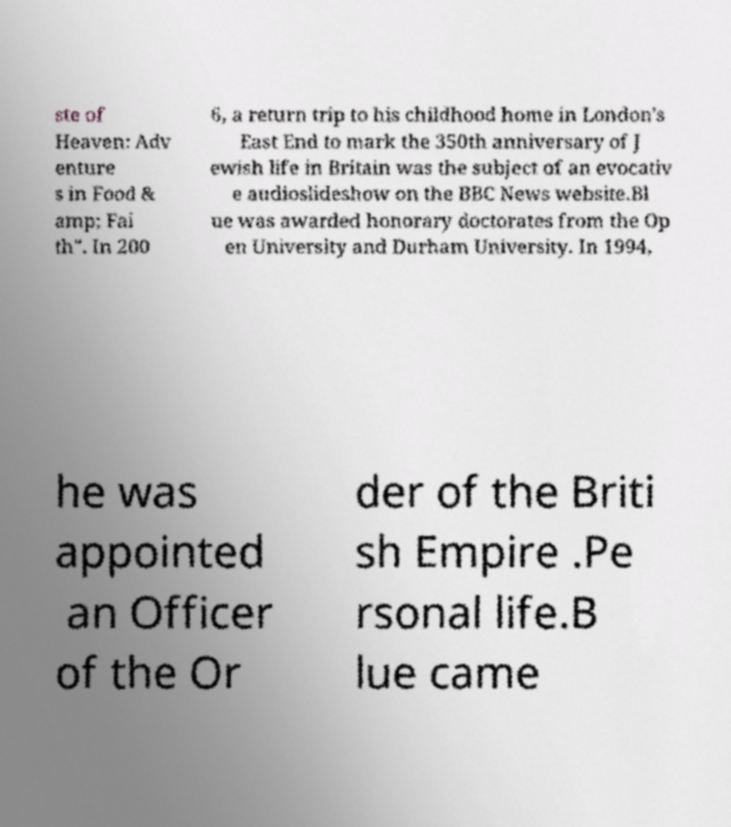I need the written content from this picture converted into text. Can you do that? ste of Heaven: Adv enture s in Food & amp; Fai th". In 200 6, a return trip to his childhood home in London's East End to mark the 350th anniversary of J ewish life in Britain was the subject of an evocativ e audioslideshow on the BBC News website.Bl ue was awarded honorary doctorates from the Op en University and Durham University. In 1994, he was appointed an Officer of the Or der of the Briti sh Empire .Pe rsonal life.B lue came 